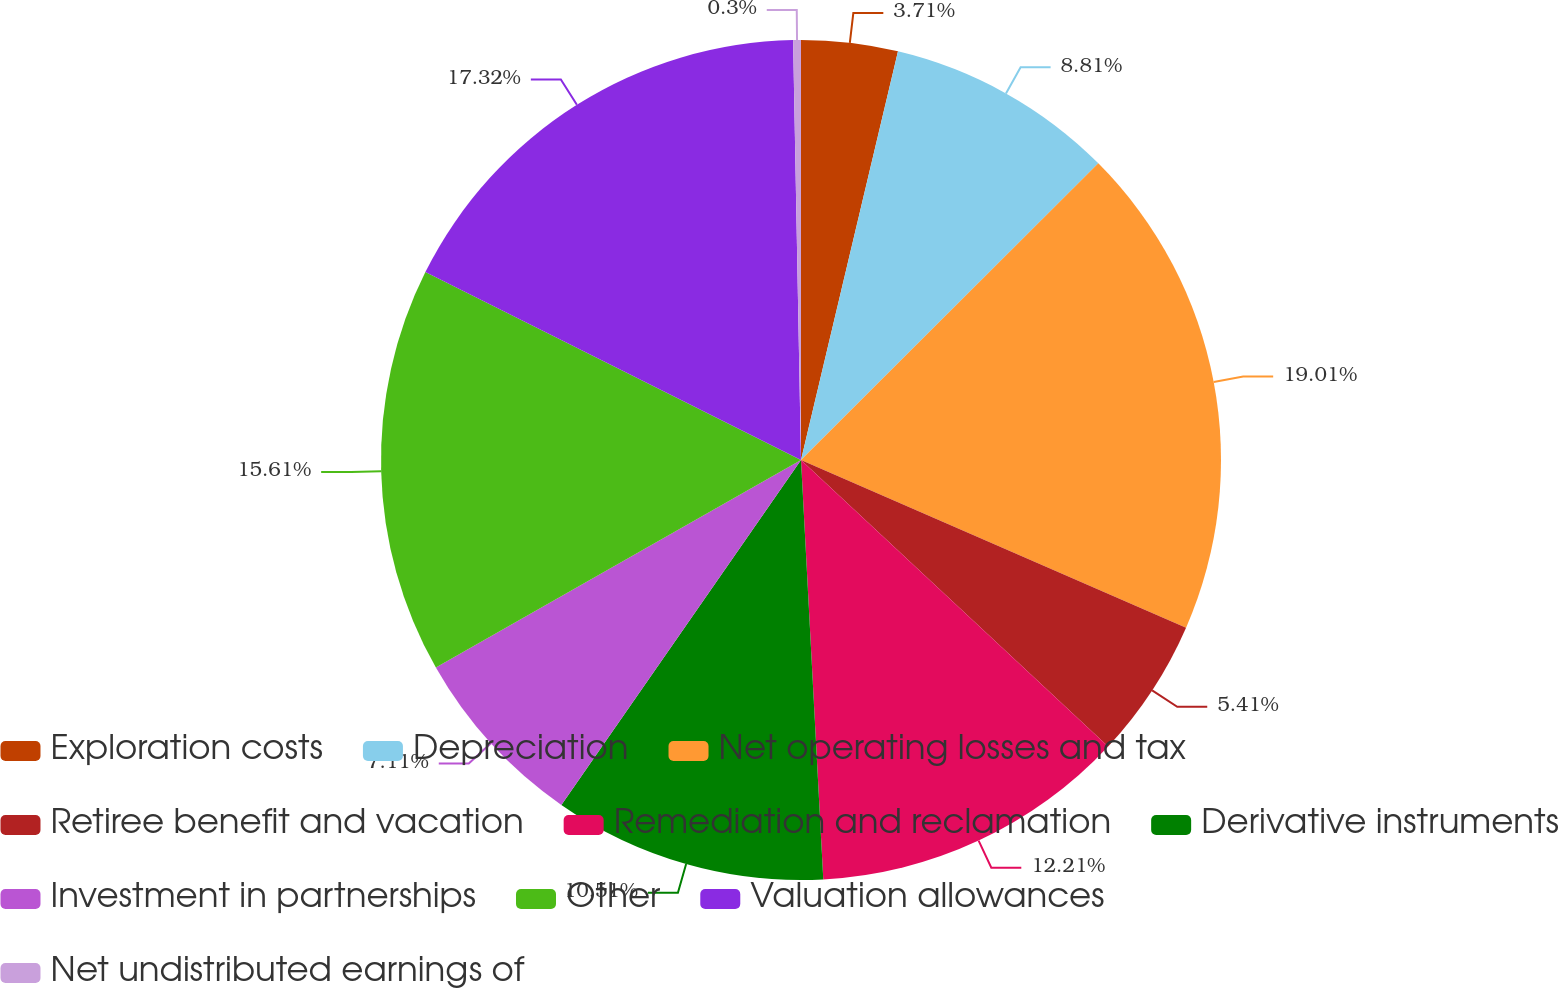<chart> <loc_0><loc_0><loc_500><loc_500><pie_chart><fcel>Exploration costs<fcel>Depreciation<fcel>Net operating losses and tax<fcel>Retiree benefit and vacation<fcel>Remediation and reclamation<fcel>Derivative instruments<fcel>Investment in partnerships<fcel>Other<fcel>Valuation allowances<fcel>Net undistributed earnings of<nl><fcel>3.71%<fcel>8.81%<fcel>19.02%<fcel>5.41%<fcel>12.21%<fcel>10.51%<fcel>7.11%<fcel>15.61%<fcel>17.32%<fcel>0.3%<nl></chart> 